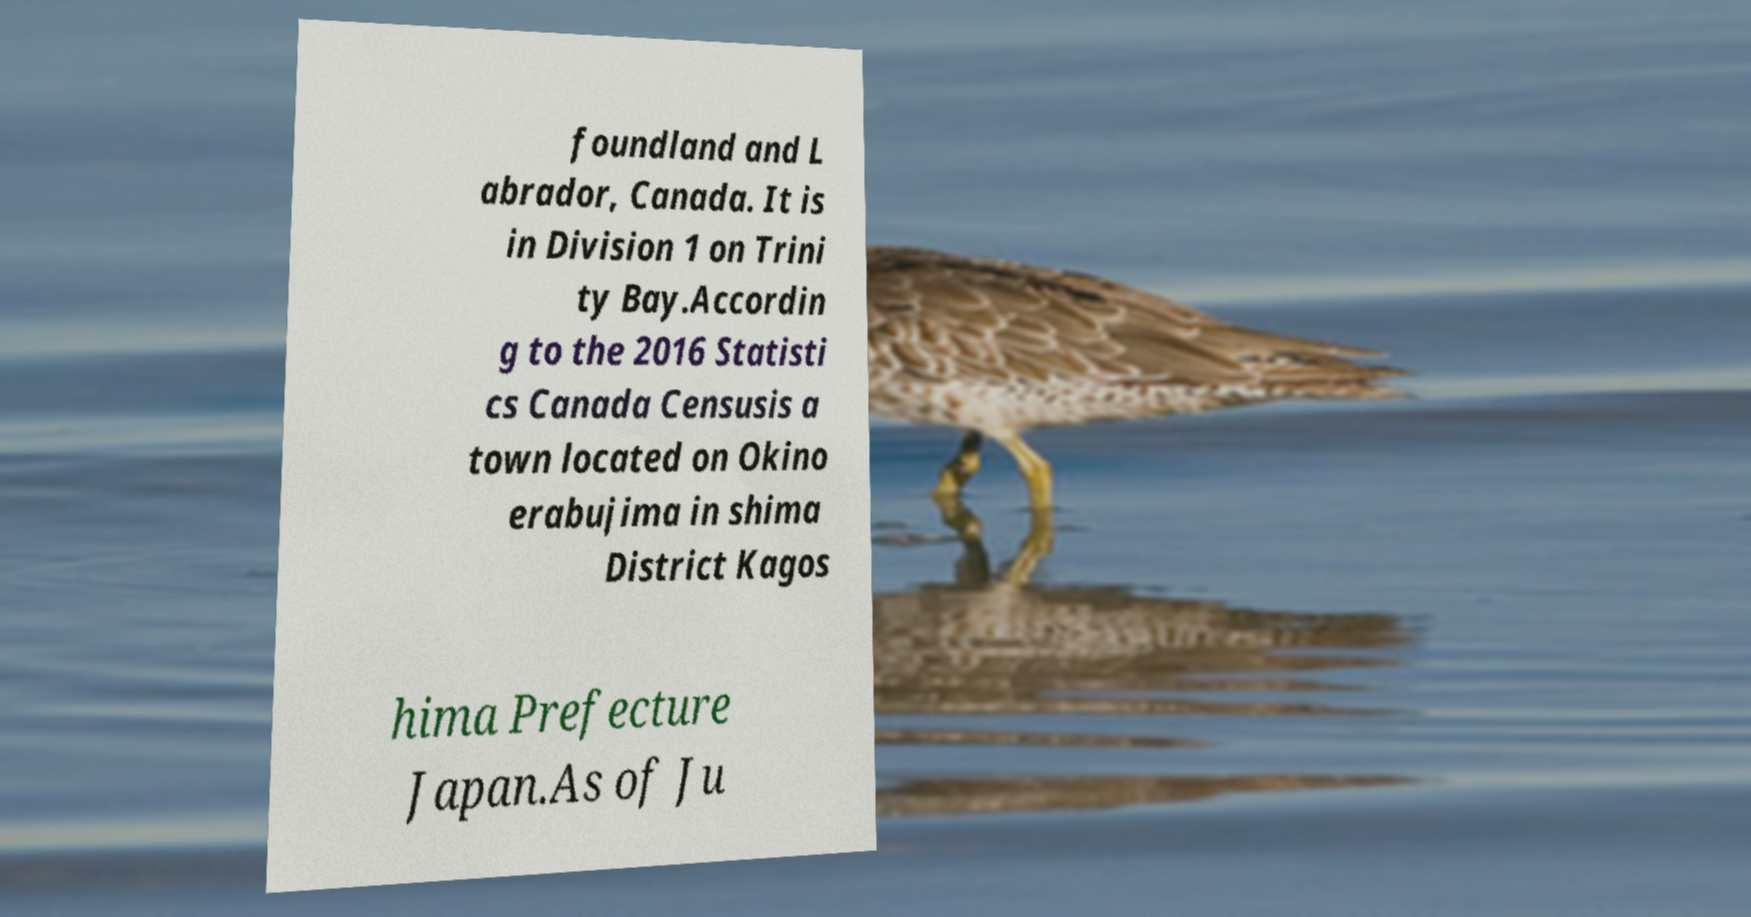For documentation purposes, I need the text within this image transcribed. Could you provide that? foundland and L abrador, Canada. It is in Division 1 on Trini ty Bay.Accordin g to the 2016 Statisti cs Canada Censusis a town located on Okino erabujima in shima District Kagos hima Prefecture Japan.As of Ju 